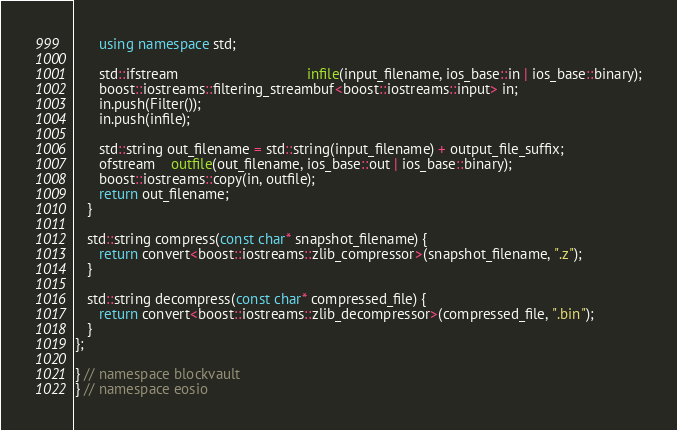Convert code to text. <code><loc_0><loc_0><loc_500><loc_500><_C++_>      using namespace std;

      std::ifstream                                infile(input_filename, ios_base::in | ios_base::binary);
      boost::iostreams::filtering_streambuf<boost::iostreams::input> in;
      in.push(Filter());
      in.push(infile);

      std::string out_filename = std::string(input_filename) + output_file_suffix;
      ofstream    outfile(out_filename, ios_base::out | ios_base::binary);
      boost::iostreams::copy(in, outfile);
      return out_filename;
   }

   std::string compress(const char* snapshot_filename) {
      return convert<boost::iostreams::zlib_compressor>(snapshot_filename, ".z");
   }

   std::string decompress(const char* compressed_file) {
      return convert<boost::iostreams::zlib_decompressor>(compressed_file, ".bin");
   }
};

} // namespace blockvault
} // namespace eosio</code> 